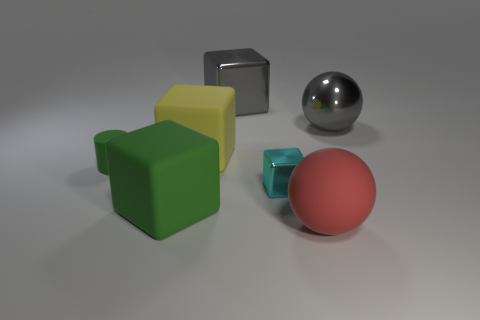Is the number of big metal things greater than the number of matte objects?
Provide a succinct answer. No. How big is the gray block that is behind the ball that is behind the ball in front of the yellow object?
Provide a succinct answer. Large. There is a metal object to the right of the red rubber thing; what size is it?
Offer a terse response. Large. How many things are big metal things or rubber objects that are to the left of the big red thing?
Offer a very short reply. 5. How many other objects are the same size as the yellow rubber cube?
Your response must be concise. 4. What is the material of the green thing that is the same shape as the tiny cyan thing?
Give a very brief answer. Rubber. Are there more small shiny blocks behind the green rubber cylinder than small gray metal cubes?
Offer a terse response. No. Are there any other things that have the same color as the small metal block?
Your response must be concise. No. What shape is the red thing that is made of the same material as the large yellow block?
Offer a terse response. Sphere. Are the tiny object right of the tiny green object and the large red ball made of the same material?
Make the answer very short. No. 